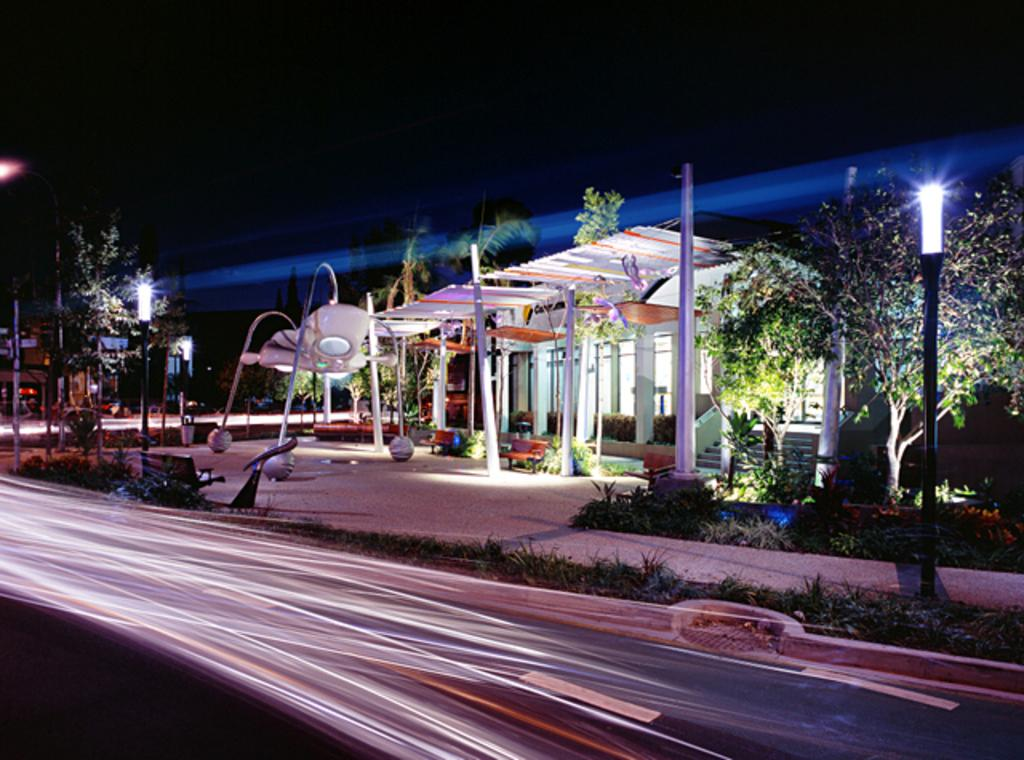What type of pathway is visible in the image? There is a road in the image. What structures can be seen along the road? Poles and lights are visible in the image. What type of vegetation is present in the image? Plants and trees are in the image. What type of seating is available in the image? Benches are in the image. What type of residential structures are visible in the image? Houses are in the image. What is the color of the background in the image? The background of the image is dark. What is the price of the building in the image? There is no building present in the image, so it is not possible to determine its price. 